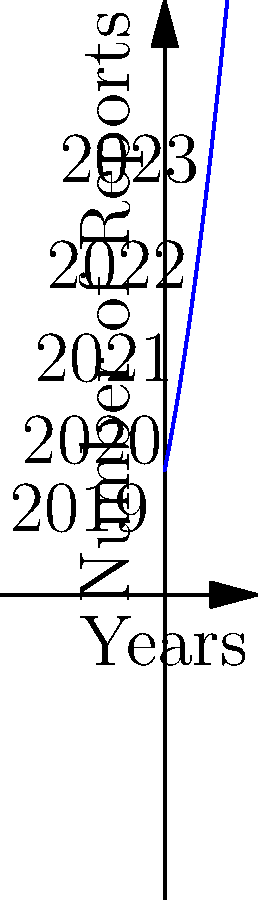The graph shows the trend of police misconduct reports over 5 years. If the trend continues, approximately how many reports are expected in 2024? To solve this problem, we need to follow these steps:

1. Observe that the graph shows a non-linear increase in reports from 2019 to 2023.

2. The curve appears to be quadratic (parabolic), suggesting the number of reports is increasing at an increasing rate.

3. We can estimate the function for this curve as:

   $f(x) = 10 + 5x + 0.5x^2$

   Where $x$ is the number of years since 2019, and $f(x)$ is the number of reports.

4. To find the expected number of reports in 2024, we need to calculate $f(5)$, as 2024 is 5 years after 2019.

5. Plugging in $x = 5$ to our function:

   $f(5) = 10 + 5(5) + 0.5(5^2)$
   $     = 10 + 25 + 0.5(25)$
   $     = 10 + 25 + 12.5$
   $     = 47.5$

6. Rounding to the nearest whole number, we expect approximately 48 reports in 2024.
Answer: 48 reports 